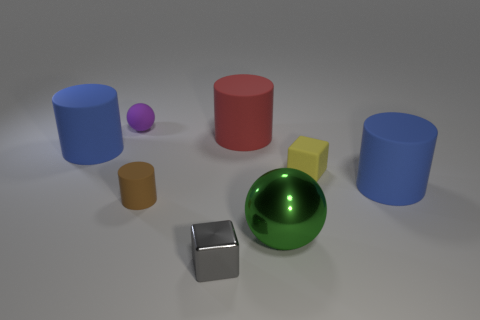How many things are either things that are in front of the small ball or large brown metal balls?
Provide a short and direct response. 7. Does the tiny purple object have the same material as the large red cylinder?
Your response must be concise. Yes. What is the size of the purple rubber object that is the same shape as the big green thing?
Provide a short and direct response. Small. Is the shape of the big object that is in front of the small rubber cylinder the same as the blue object that is left of the red rubber cylinder?
Ensure brevity in your answer.  No. Is the size of the rubber cube the same as the matte thing on the left side of the small sphere?
Offer a terse response. No. How many other things are made of the same material as the tiny purple sphere?
Offer a very short reply. 5. Is there any other thing that is the same shape as the yellow thing?
Offer a very short reply. Yes. What is the color of the ball right of the purple thing behind the red cylinder that is in front of the purple matte object?
Provide a succinct answer. Green. What is the shape of the tiny object that is both in front of the yellow thing and behind the large green ball?
Your answer should be compact. Cylinder. Are there any other things that have the same size as the red rubber cylinder?
Ensure brevity in your answer.  Yes. 